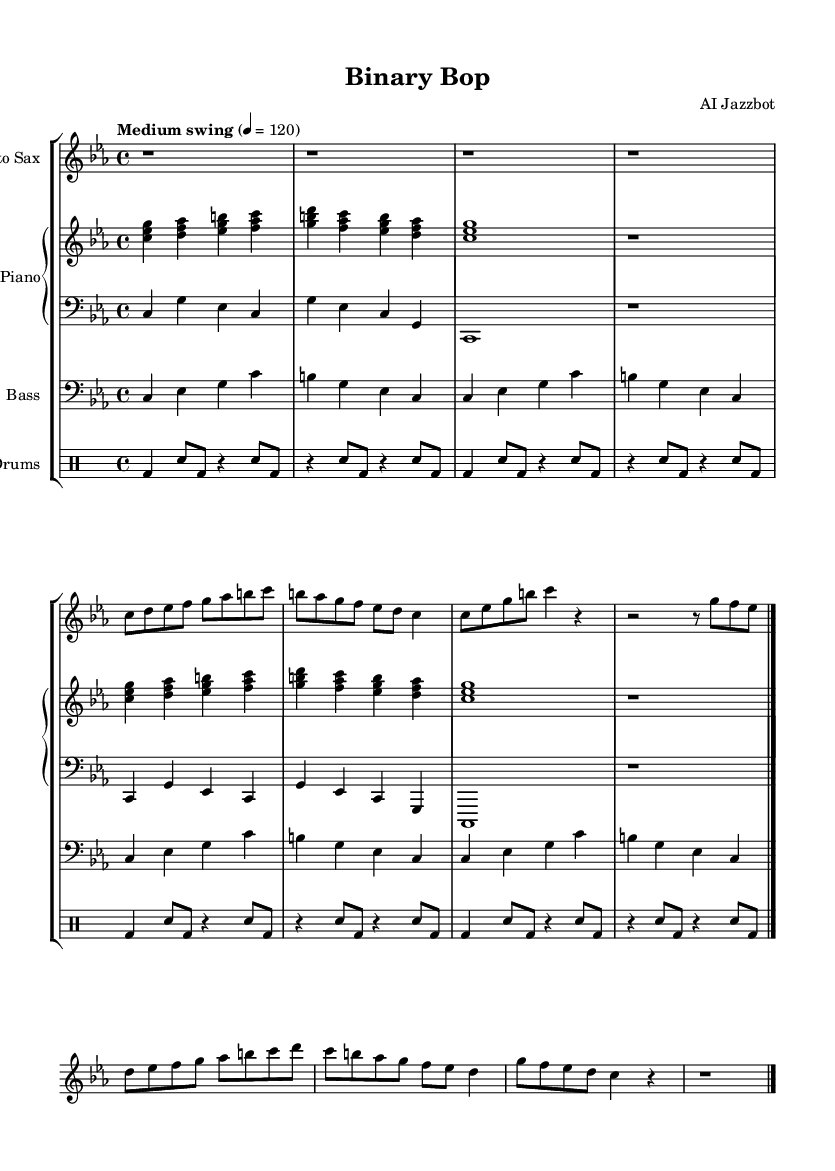What is the key signature of this music? The key signature is located at the beginning of the staff and shows three flats, indicating the key of C minor.
Answer: C minor What is the time signature of this piece? The time signature is found at the beginning of the score right after the key signature, showing a 4 over 4 notation, meaning there are four beats in each measure.
Answer: 4/4 What is the tempo marking for this piece? The tempo marking is present at the beginning of the score and reads "Medium swing" with a metronome marking of 120 beats per minute, indicating the desired speed of the performance.
Answer: Medium swing, 4 = 120 How many measures are there in the saxophone part? To determine the number of measures, we count the number of vertical lines (bar lines) in the saxophone part; here, there are eight measures, as indicated by the bar lines.
Answer: 8 What is the rhythmic pattern of the bass line? The bass line alternates between quarter notes and is comprised of similar note patterns; analyzing it reveals that every measure is filled with quarter notes in a repeating pattern.
Answer: Repeating quarter notes What style of jazz is reflected in this composition? The overall style is indicated in the tempo marking "Medium swing," which suggests a relaxed, laid-back feeling characteristic of cool jazz.
Answer: Cool jazz What musical role does the piano play in this piece? The piano part consists of both a right-hand melody and a left-hand accompaniment, providing harmonic support and filling in the texture of the overall ensemble sound.
Answer: Harmonic support and texture filling 